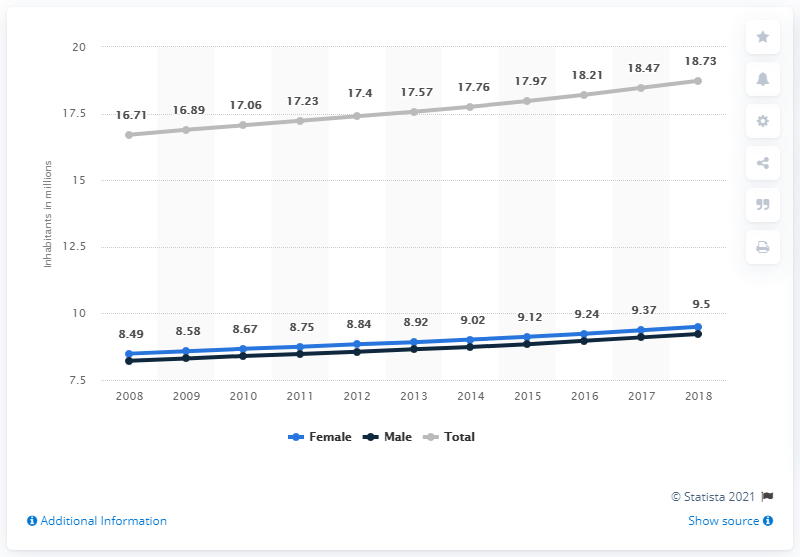Mention a couple of crucial points in this snapshot. In 2008, the population of Chile began to show an upward trend. 